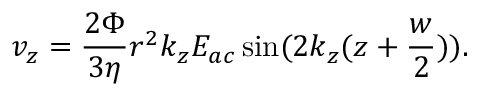Convert formula to latex. <formula><loc_0><loc_0><loc_500><loc_500>v _ { z } = \frac { 2 \Phi } { 3 \eta } r ^ { 2 } k _ { z } E _ { a c } \sin ( 2 k _ { z } ( z + \frac { w } { 2 } ) ) .</formula> 